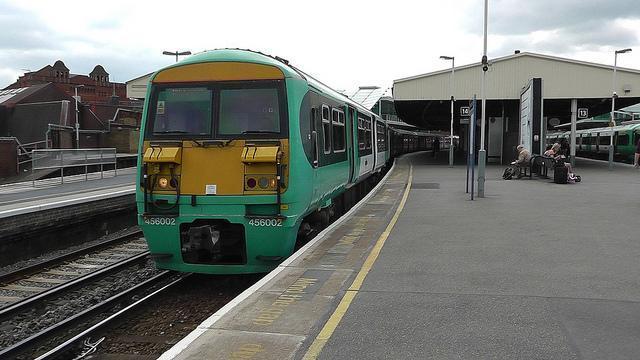How many people are waiting for the train?
Give a very brief answer. 2. How many people are standing on the train platform?
Give a very brief answer. 0. How many tracks are to the right of the train?
Give a very brief answer. 1. How many cats are on the top shelf?
Give a very brief answer. 0. 